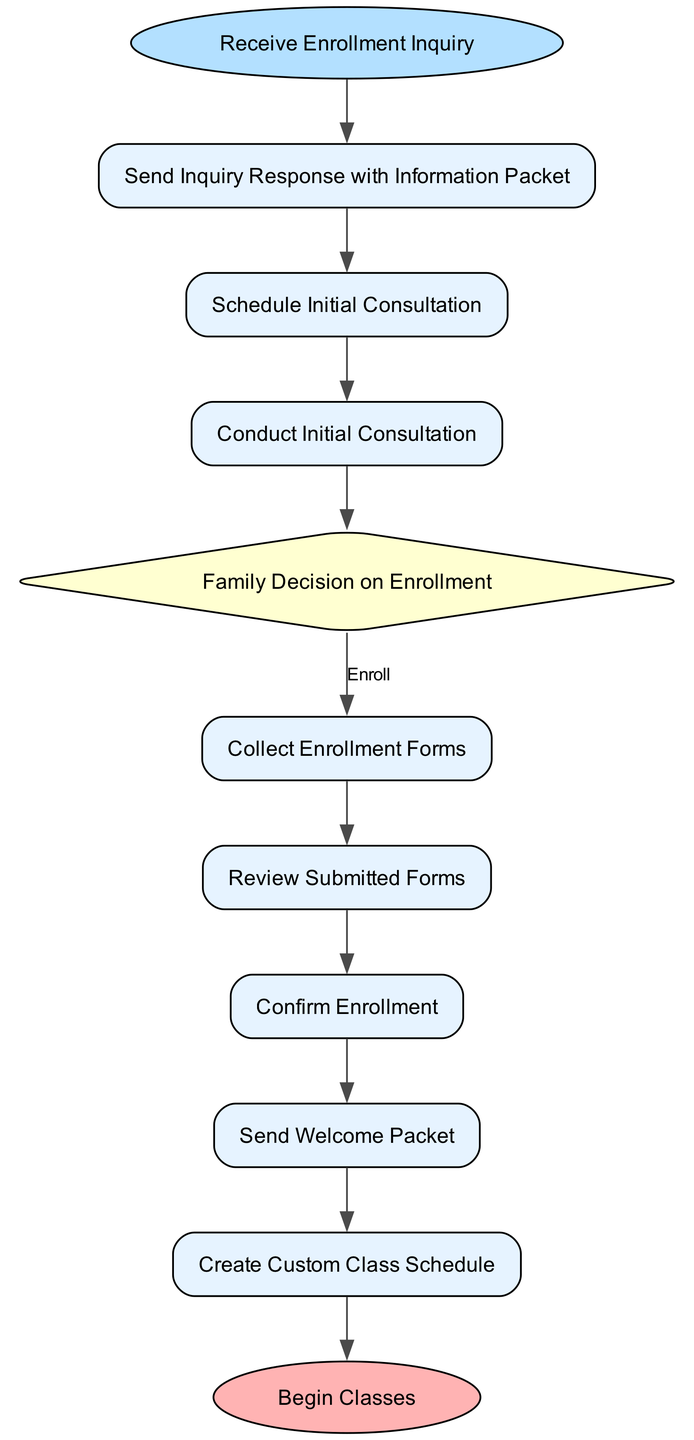What is the first activity in the enrollment process? The first activity in the enrollment process is indicated by the start node, which is "Receive Enrollment Inquiry."
Answer: Receive Enrollment Inquiry How many total activities are present in the diagram? By counting all the activities listed in the diagram, there are a total of 10 activities from the start to the end.
Answer: 10 What is the decision made after conducting the initial consultation? After conducting the initial consultation, the family must decide between two options: "Enroll" or "Do Not Enroll."
Answer: Family Decision on Enrollment What activity follows after confirming enrollment? The next activity that follows confirming enrollment is "Send Welcome Packet." This is shown as a direct connection in the flow of the diagram.
Answer: Send Welcome Packet What happens if the family decides not to enroll? If the family decides not to enroll, the process leads to the end of the process, indicated by "End Process."
Answer: End Process How many decision points are there in the flow? There is only one decision point in the flow, which is the "Family Decision on Enrollment."
Answer: 1 What are the conditions under which the enrollment process can continue? The conditions that allow the enrollment process to continue are if the family decides to "Enroll." This indicates a successful continuation of the process.
Answer: Enroll What is the last activity in the diagram? The last activity in the diagram is indicated by the end node, which is "Begin Classes."
Answer: Begin Classes Which activity occurs just before creating a custom class schedule? The activity that occurs just before creating a custom class schedule is "Send Welcome Packet," as per the sequential flow established in the diagram.
Answer: Send Welcome Packet 